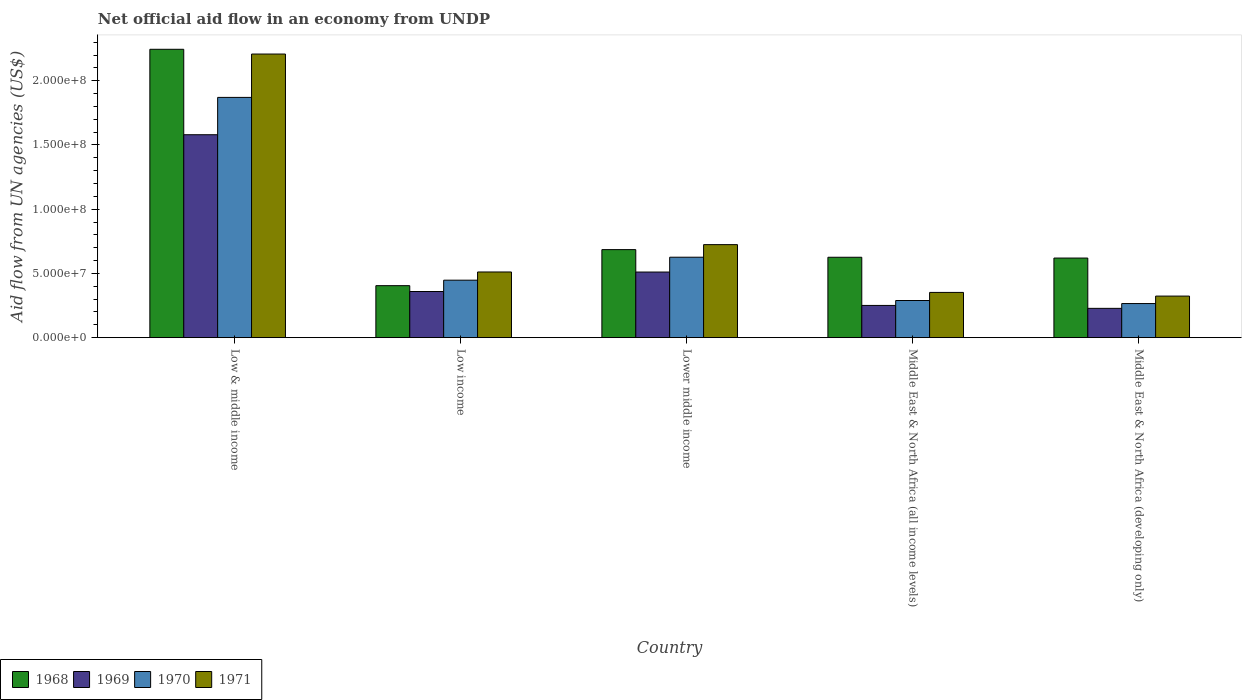Are the number of bars per tick equal to the number of legend labels?
Give a very brief answer. Yes. Are the number of bars on each tick of the X-axis equal?
Offer a terse response. Yes. What is the net official aid flow in 1969 in Middle East & North Africa (all income levels)?
Provide a succinct answer. 2.51e+07. Across all countries, what is the maximum net official aid flow in 1968?
Give a very brief answer. 2.24e+08. Across all countries, what is the minimum net official aid flow in 1969?
Provide a succinct answer. 2.28e+07. In which country was the net official aid flow in 1969 minimum?
Keep it short and to the point. Middle East & North Africa (developing only). What is the total net official aid flow in 1968 in the graph?
Make the answer very short. 4.58e+08. What is the difference between the net official aid flow in 1971 in Lower middle income and that in Middle East & North Africa (all income levels)?
Provide a succinct answer. 3.72e+07. What is the difference between the net official aid flow in 1970 in Lower middle income and the net official aid flow in 1969 in Low income?
Offer a very short reply. 2.67e+07. What is the average net official aid flow in 1968 per country?
Provide a short and direct response. 9.16e+07. What is the difference between the net official aid flow of/in 1971 and net official aid flow of/in 1969 in Lower middle income?
Provide a succinct answer. 2.13e+07. What is the ratio of the net official aid flow in 1970 in Lower middle income to that in Middle East & North Africa (all income levels)?
Provide a short and direct response. 2.17. What is the difference between the highest and the second highest net official aid flow in 1971?
Keep it short and to the point. 1.70e+08. What is the difference between the highest and the lowest net official aid flow in 1969?
Provide a succinct answer. 1.35e+08. Is it the case that in every country, the sum of the net official aid flow in 1970 and net official aid flow in 1969 is greater than the sum of net official aid flow in 1971 and net official aid flow in 1968?
Your answer should be compact. No. What does the 1st bar from the right in Low income represents?
Offer a very short reply. 1971. Is it the case that in every country, the sum of the net official aid flow in 1971 and net official aid flow in 1968 is greater than the net official aid flow in 1969?
Provide a succinct answer. Yes. How many bars are there?
Provide a short and direct response. 20. Are all the bars in the graph horizontal?
Ensure brevity in your answer.  No. How many countries are there in the graph?
Provide a succinct answer. 5. Are the values on the major ticks of Y-axis written in scientific E-notation?
Keep it short and to the point. Yes. Where does the legend appear in the graph?
Give a very brief answer. Bottom left. How are the legend labels stacked?
Your response must be concise. Horizontal. What is the title of the graph?
Your response must be concise. Net official aid flow in an economy from UNDP. What is the label or title of the Y-axis?
Provide a short and direct response. Aid flow from UN agencies (US$). What is the Aid flow from UN agencies (US$) of 1968 in Low & middle income?
Give a very brief answer. 2.24e+08. What is the Aid flow from UN agencies (US$) of 1969 in Low & middle income?
Ensure brevity in your answer.  1.58e+08. What is the Aid flow from UN agencies (US$) in 1970 in Low & middle income?
Your response must be concise. 1.87e+08. What is the Aid flow from UN agencies (US$) in 1971 in Low & middle income?
Provide a short and direct response. 2.21e+08. What is the Aid flow from UN agencies (US$) of 1968 in Low income?
Your answer should be very brief. 4.05e+07. What is the Aid flow from UN agencies (US$) in 1969 in Low income?
Ensure brevity in your answer.  3.59e+07. What is the Aid flow from UN agencies (US$) in 1970 in Low income?
Offer a terse response. 4.48e+07. What is the Aid flow from UN agencies (US$) of 1971 in Low income?
Keep it short and to the point. 5.11e+07. What is the Aid flow from UN agencies (US$) in 1968 in Lower middle income?
Your answer should be compact. 6.85e+07. What is the Aid flow from UN agencies (US$) of 1969 in Lower middle income?
Your answer should be very brief. 5.11e+07. What is the Aid flow from UN agencies (US$) of 1970 in Lower middle income?
Your answer should be very brief. 6.26e+07. What is the Aid flow from UN agencies (US$) of 1971 in Lower middle income?
Offer a very short reply. 7.24e+07. What is the Aid flow from UN agencies (US$) in 1968 in Middle East & North Africa (all income levels)?
Keep it short and to the point. 6.26e+07. What is the Aid flow from UN agencies (US$) of 1969 in Middle East & North Africa (all income levels)?
Make the answer very short. 2.51e+07. What is the Aid flow from UN agencies (US$) in 1970 in Middle East & North Africa (all income levels)?
Provide a succinct answer. 2.89e+07. What is the Aid flow from UN agencies (US$) in 1971 in Middle East & North Africa (all income levels)?
Offer a very short reply. 3.52e+07. What is the Aid flow from UN agencies (US$) in 1968 in Middle East & North Africa (developing only)?
Give a very brief answer. 6.20e+07. What is the Aid flow from UN agencies (US$) in 1969 in Middle East & North Africa (developing only)?
Your answer should be compact. 2.28e+07. What is the Aid flow from UN agencies (US$) in 1970 in Middle East & North Africa (developing only)?
Provide a short and direct response. 2.66e+07. What is the Aid flow from UN agencies (US$) of 1971 in Middle East & North Africa (developing only)?
Offer a very short reply. 3.24e+07. Across all countries, what is the maximum Aid flow from UN agencies (US$) of 1968?
Provide a short and direct response. 2.24e+08. Across all countries, what is the maximum Aid flow from UN agencies (US$) of 1969?
Give a very brief answer. 1.58e+08. Across all countries, what is the maximum Aid flow from UN agencies (US$) of 1970?
Ensure brevity in your answer.  1.87e+08. Across all countries, what is the maximum Aid flow from UN agencies (US$) in 1971?
Ensure brevity in your answer.  2.21e+08. Across all countries, what is the minimum Aid flow from UN agencies (US$) of 1968?
Keep it short and to the point. 4.05e+07. Across all countries, what is the minimum Aid flow from UN agencies (US$) in 1969?
Keep it short and to the point. 2.28e+07. Across all countries, what is the minimum Aid flow from UN agencies (US$) in 1970?
Provide a succinct answer. 2.66e+07. Across all countries, what is the minimum Aid flow from UN agencies (US$) of 1971?
Offer a very short reply. 3.24e+07. What is the total Aid flow from UN agencies (US$) of 1968 in the graph?
Your answer should be very brief. 4.58e+08. What is the total Aid flow from UN agencies (US$) of 1969 in the graph?
Ensure brevity in your answer.  2.93e+08. What is the total Aid flow from UN agencies (US$) of 1970 in the graph?
Your response must be concise. 3.50e+08. What is the total Aid flow from UN agencies (US$) in 1971 in the graph?
Keep it short and to the point. 4.12e+08. What is the difference between the Aid flow from UN agencies (US$) of 1968 in Low & middle income and that in Low income?
Keep it short and to the point. 1.84e+08. What is the difference between the Aid flow from UN agencies (US$) in 1969 in Low & middle income and that in Low income?
Provide a short and direct response. 1.22e+08. What is the difference between the Aid flow from UN agencies (US$) in 1970 in Low & middle income and that in Low income?
Ensure brevity in your answer.  1.42e+08. What is the difference between the Aid flow from UN agencies (US$) in 1971 in Low & middle income and that in Low income?
Give a very brief answer. 1.70e+08. What is the difference between the Aid flow from UN agencies (US$) of 1968 in Low & middle income and that in Lower middle income?
Your response must be concise. 1.56e+08. What is the difference between the Aid flow from UN agencies (US$) in 1969 in Low & middle income and that in Lower middle income?
Your answer should be compact. 1.07e+08. What is the difference between the Aid flow from UN agencies (US$) of 1970 in Low & middle income and that in Lower middle income?
Your answer should be very brief. 1.24e+08. What is the difference between the Aid flow from UN agencies (US$) of 1971 in Low & middle income and that in Lower middle income?
Your response must be concise. 1.48e+08. What is the difference between the Aid flow from UN agencies (US$) in 1968 in Low & middle income and that in Middle East & North Africa (all income levels)?
Keep it short and to the point. 1.62e+08. What is the difference between the Aid flow from UN agencies (US$) in 1969 in Low & middle income and that in Middle East & North Africa (all income levels)?
Your answer should be very brief. 1.33e+08. What is the difference between the Aid flow from UN agencies (US$) of 1970 in Low & middle income and that in Middle East & North Africa (all income levels)?
Your answer should be very brief. 1.58e+08. What is the difference between the Aid flow from UN agencies (US$) in 1971 in Low & middle income and that in Middle East & North Africa (all income levels)?
Give a very brief answer. 1.86e+08. What is the difference between the Aid flow from UN agencies (US$) of 1968 in Low & middle income and that in Middle East & North Africa (developing only)?
Offer a terse response. 1.63e+08. What is the difference between the Aid flow from UN agencies (US$) of 1969 in Low & middle income and that in Middle East & North Africa (developing only)?
Your answer should be very brief. 1.35e+08. What is the difference between the Aid flow from UN agencies (US$) in 1970 in Low & middle income and that in Middle East & North Africa (developing only)?
Make the answer very short. 1.60e+08. What is the difference between the Aid flow from UN agencies (US$) of 1971 in Low & middle income and that in Middle East & North Africa (developing only)?
Make the answer very short. 1.88e+08. What is the difference between the Aid flow from UN agencies (US$) of 1968 in Low income and that in Lower middle income?
Provide a short and direct response. -2.81e+07. What is the difference between the Aid flow from UN agencies (US$) in 1969 in Low income and that in Lower middle income?
Give a very brief answer. -1.52e+07. What is the difference between the Aid flow from UN agencies (US$) in 1970 in Low income and that in Lower middle income?
Provide a succinct answer. -1.79e+07. What is the difference between the Aid flow from UN agencies (US$) of 1971 in Low income and that in Lower middle income?
Your response must be concise. -2.13e+07. What is the difference between the Aid flow from UN agencies (US$) in 1968 in Low income and that in Middle East & North Africa (all income levels)?
Make the answer very short. -2.21e+07. What is the difference between the Aid flow from UN agencies (US$) of 1969 in Low income and that in Middle East & North Africa (all income levels)?
Ensure brevity in your answer.  1.08e+07. What is the difference between the Aid flow from UN agencies (US$) in 1970 in Low income and that in Middle East & North Africa (all income levels)?
Your response must be concise. 1.58e+07. What is the difference between the Aid flow from UN agencies (US$) of 1971 in Low income and that in Middle East & North Africa (all income levels)?
Your answer should be very brief. 1.59e+07. What is the difference between the Aid flow from UN agencies (US$) in 1968 in Low income and that in Middle East & North Africa (developing only)?
Give a very brief answer. -2.15e+07. What is the difference between the Aid flow from UN agencies (US$) in 1969 in Low income and that in Middle East & North Africa (developing only)?
Give a very brief answer. 1.31e+07. What is the difference between the Aid flow from UN agencies (US$) in 1970 in Low income and that in Middle East & North Africa (developing only)?
Keep it short and to the point. 1.82e+07. What is the difference between the Aid flow from UN agencies (US$) in 1971 in Low income and that in Middle East & North Africa (developing only)?
Offer a very short reply. 1.88e+07. What is the difference between the Aid flow from UN agencies (US$) in 1968 in Lower middle income and that in Middle East & North Africa (all income levels)?
Make the answer very short. 5.95e+06. What is the difference between the Aid flow from UN agencies (US$) of 1969 in Lower middle income and that in Middle East & North Africa (all income levels)?
Your response must be concise. 2.60e+07. What is the difference between the Aid flow from UN agencies (US$) of 1970 in Lower middle income and that in Middle East & North Africa (all income levels)?
Your answer should be very brief. 3.37e+07. What is the difference between the Aid flow from UN agencies (US$) in 1971 in Lower middle income and that in Middle East & North Africa (all income levels)?
Provide a succinct answer. 3.72e+07. What is the difference between the Aid flow from UN agencies (US$) in 1968 in Lower middle income and that in Middle East & North Africa (developing only)?
Keep it short and to the point. 6.57e+06. What is the difference between the Aid flow from UN agencies (US$) in 1969 in Lower middle income and that in Middle East & North Africa (developing only)?
Offer a very short reply. 2.83e+07. What is the difference between the Aid flow from UN agencies (US$) of 1970 in Lower middle income and that in Middle East & North Africa (developing only)?
Your answer should be compact. 3.61e+07. What is the difference between the Aid flow from UN agencies (US$) of 1971 in Lower middle income and that in Middle East & North Africa (developing only)?
Provide a short and direct response. 4.01e+07. What is the difference between the Aid flow from UN agencies (US$) in 1968 in Middle East & North Africa (all income levels) and that in Middle East & North Africa (developing only)?
Your answer should be compact. 6.20e+05. What is the difference between the Aid flow from UN agencies (US$) in 1969 in Middle East & North Africa (all income levels) and that in Middle East & North Africa (developing only)?
Your answer should be very brief. 2.27e+06. What is the difference between the Aid flow from UN agencies (US$) in 1970 in Middle East & North Africa (all income levels) and that in Middle East & North Africa (developing only)?
Your response must be concise. 2.37e+06. What is the difference between the Aid flow from UN agencies (US$) of 1971 in Middle East & North Africa (all income levels) and that in Middle East & North Africa (developing only)?
Your answer should be very brief. 2.87e+06. What is the difference between the Aid flow from UN agencies (US$) of 1968 in Low & middle income and the Aid flow from UN agencies (US$) of 1969 in Low income?
Keep it short and to the point. 1.89e+08. What is the difference between the Aid flow from UN agencies (US$) in 1968 in Low & middle income and the Aid flow from UN agencies (US$) in 1970 in Low income?
Keep it short and to the point. 1.80e+08. What is the difference between the Aid flow from UN agencies (US$) in 1968 in Low & middle income and the Aid flow from UN agencies (US$) in 1971 in Low income?
Ensure brevity in your answer.  1.73e+08. What is the difference between the Aid flow from UN agencies (US$) of 1969 in Low & middle income and the Aid flow from UN agencies (US$) of 1970 in Low income?
Offer a very short reply. 1.13e+08. What is the difference between the Aid flow from UN agencies (US$) in 1969 in Low & middle income and the Aid flow from UN agencies (US$) in 1971 in Low income?
Give a very brief answer. 1.07e+08. What is the difference between the Aid flow from UN agencies (US$) of 1970 in Low & middle income and the Aid flow from UN agencies (US$) of 1971 in Low income?
Keep it short and to the point. 1.36e+08. What is the difference between the Aid flow from UN agencies (US$) in 1968 in Low & middle income and the Aid flow from UN agencies (US$) in 1969 in Lower middle income?
Your answer should be very brief. 1.73e+08. What is the difference between the Aid flow from UN agencies (US$) in 1968 in Low & middle income and the Aid flow from UN agencies (US$) in 1970 in Lower middle income?
Offer a very short reply. 1.62e+08. What is the difference between the Aid flow from UN agencies (US$) in 1968 in Low & middle income and the Aid flow from UN agencies (US$) in 1971 in Lower middle income?
Your answer should be compact. 1.52e+08. What is the difference between the Aid flow from UN agencies (US$) in 1969 in Low & middle income and the Aid flow from UN agencies (US$) in 1970 in Lower middle income?
Your response must be concise. 9.54e+07. What is the difference between the Aid flow from UN agencies (US$) in 1969 in Low & middle income and the Aid flow from UN agencies (US$) in 1971 in Lower middle income?
Provide a short and direct response. 8.56e+07. What is the difference between the Aid flow from UN agencies (US$) of 1970 in Low & middle income and the Aid flow from UN agencies (US$) of 1971 in Lower middle income?
Your answer should be compact. 1.15e+08. What is the difference between the Aid flow from UN agencies (US$) in 1968 in Low & middle income and the Aid flow from UN agencies (US$) in 1969 in Middle East & North Africa (all income levels)?
Your answer should be very brief. 1.99e+08. What is the difference between the Aid flow from UN agencies (US$) in 1968 in Low & middle income and the Aid flow from UN agencies (US$) in 1970 in Middle East & North Africa (all income levels)?
Your answer should be compact. 1.96e+08. What is the difference between the Aid flow from UN agencies (US$) in 1968 in Low & middle income and the Aid flow from UN agencies (US$) in 1971 in Middle East & North Africa (all income levels)?
Provide a short and direct response. 1.89e+08. What is the difference between the Aid flow from UN agencies (US$) of 1969 in Low & middle income and the Aid flow from UN agencies (US$) of 1970 in Middle East & North Africa (all income levels)?
Provide a succinct answer. 1.29e+08. What is the difference between the Aid flow from UN agencies (US$) in 1969 in Low & middle income and the Aid flow from UN agencies (US$) in 1971 in Middle East & North Africa (all income levels)?
Your answer should be compact. 1.23e+08. What is the difference between the Aid flow from UN agencies (US$) of 1970 in Low & middle income and the Aid flow from UN agencies (US$) of 1971 in Middle East & North Africa (all income levels)?
Give a very brief answer. 1.52e+08. What is the difference between the Aid flow from UN agencies (US$) in 1968 in Low & middle income and the Aid flow from UN agencies (US$) in 1969 in Middle East & North Africa (developing only)?
Offer a terse response. 2.02e+08. What is the difference between the Aid flow from UN agencies (US$) in 1968 in Low & middle income and the Aid flow from UN agencies (US$) in 1970 in Middle East & North Africa (developing only)?
Make the answer very short. 1.98e+08. What is the difference between the Aid flow from UN agencies (US$) in 1968 in Low & middle income and the Aid flow from UN agencies (US$) in 1971 in Middle East & North Africa (developing only)?
Keep it short and to the point. 1.92e+08. What is the difference between the Aid flow from UN agencies (US$) of 1969 in Low & middle income and the Aid flow from UN agencies (US$) of 1970 in Middle East & North Africa (developing only)?
Keep it short and to the point. 1.31e+08. What is the difference between the Aid flow from UN agencies (US$) of 1969 in Low & middle income and the Aid flow from UN agencies (US$) of 1971 in Middle East & North Africa (developing only)?
Give a very brief answer. 1.26e+08. What is the difference between the Aid flow from UN agencies (US$) of 1970 in Low & middle income and the Aid flow from UN agencies (US$) of 1971 in Middle East & North Africa (developing only)?
Provide a short and direct response. 1.55e+08. What is the difference between the Aid flow from UN agencies (US$) of 1968 in Low income and the Aid flow from UN agencies (US$) of 1969 in Lower middle income?
Give a very brief answer. -1.06e+07. What is the difference between the Aid flow from UN agencies (US$) of 1968 in Low income and the Aid flow from UN agencies (US$) of 1970 in Lower middle income?
Provide a short and direct response. -2.22e+07. What is the difference between the Aid flow from UN agencies (US$) of 1968 in Low income and the Aid flow from UN agencies (US$) of 1971 in Lower middle income?
Make the answer very short. -3.19e+07. What is the difference between the Aid flow from UN agencies (US$) in 1969 in Low income and the Aid flow from UN agencies (US$) in 1970 in Lower middle income?
Your answer should be very brief. -2.67e+07. What is the difference between the Aid flow from UN agencies (US$) of 1969 in Low income and the Aid flow from UN agencies (US$) of 1971 in Lower middle income?
Offer a very short reply. -3.65e+07. What is the difference between the Aid flow from UN agencies (US$) in 1970 in Low income and the Aid flow from UN agencies (US$) in 1971 in Lower middle income?
Your answer should be very brief. -2.77e+07. What is the difference between the Aid flow from UN agencies (US$) of 1968 in Low income and the Aid flow from UN agencies (US$) of 1969 in Middle East & North Africa (all income levels)?
Keep it short and to the point. 1.54e+07. What is the difference between the Aid flow from UN agencies (US$) of 1968 in Low income and the Aid flow from UN agencies (US$) of 1970 in Middle East & North Africa (all income levels)?
Offer a very short reply. 1.16e+07. What is the difference between the Aid flow from UN agencies (US$) in 1968 in Low income and the Aid flow from UN agencies (US$) in 1971 in Middle East & North Africa (all income levels)?
Your answer should be compact. 5.25e+06. What is the difference between the Aid flow from UN agencies (US$) of 1969 in Low income and the Aid flow from UN agencies (US$) of 1970 in Middle East & North Africa (all income levels)?
Offer a very short reply. 7.01e+06. What is the difference between the Aid flow from UN agencies (US$) of 1970 in Low income and the Aid flow from UN agencies (US$) of 1971 in Middle East & North Africa (all income levels)?
Make the answer very short. 9.52e+06. What is the difference between the Aid flow from UN agencies (US$) in 1968 in Low income and the Aid flow from UN agencies (US$) in 1969 in Middle East & North Africa (developing only)?
Offer a very short reply. 1.77e+07. What is the difference between the Aid flow from UN agencies (US$) in 1968 in Low income and the Aid flow from UN agencies (US$) in 1970 in Middle East & North Africa (developing only)?
Keep it short and to the point. 1.39e+07. What is the difference between the Aid flow from UN agencies (US$) in 1968 in Low income and the Aid flow from UN agencies (US$) in 1971 in Middle East & North Africa (developing only)?
Keep it short and to the point. 8.12e+06. What is the difference between the Aid flow from UN agencies (US$) of 1969 in Low income and the Aid flow from UN agencies (US$) of 1970 in Middle East & North Africa (developing only)?
Your answer should be very brief. 9.38e+06. What is the difference between the Aid flow from UN agencies (US$) of 1969 in Low income and the Aid flow from UN agencies (US$) of 1971 in Middle East & North Africa (developing only)?
Offer a very short reply. 3.57e+06. What is the difference between the Aid flow from UN agencies (US$) in 1970 in Low income and the Aid flow from UN agencies (US$) in 1971 in Middle East & North Africa (developing only)?
Provide a succinct answer. 1.24e+07. What is the difference between the Aid flow from UN agencies (US$) in 1968 in Lower middle income and the Aid flow from UN agencies (US$) in 1969 in Middle East & North Africa (all income levels)?
Keep it short and to the point. 4.34e+07. What is the difference between the Aid flow from UN agencies (US$) of 1968 in Lower middle income and the Aid flow from UN agencies (US$) of 1970 in Middle East & North Africa (all income levels)?
Keep it short and to the point. 3.96e+07. What is the difference between the Aid flow from UN agencies (US$) of 1968 in Lower middle income and the Aid flow from UN agencies (US$) of 1971 in Middle East & North Africa (all income levels)?
Ensure brevity in your answer.  3.33e+07. What is the difference between the Aid flow from UN agencies (US$) in 1969 in Lower middle income and the Aid flow from UN agencies (US$) in 1970 in Middle East & North Africa (all income levels)?
Offer a very short reply. 2.22e+07. What is the difference between the Aid flow from UN agencies (US$) of 1969 in Lower middle income and the Aid flow from UN agencies (US$) of 1971 in Middle East & North Africa (all income levels)?
Offer a very short reply. 1.59e+07. What is the difference between the Aid flow from UN agencies (US$) of 1970 in Lower middle income and the Aid flow from UN agencies (US$) of 1971 in Middle East & North Africa (all income levels)?
Your answer should be very brief. 2.74e+07. What is the difference between the Aid flow from UN agencies (US$) in 1968 in Lower middle income and the Aid flow from UN agencies (US$) in 1969 in Middle East & North Africa (developing only)?
Your answer should be compact. 4.57e+07. What is the difference between the Aid flow from UN agencies (US$) in 1968 in Lower middle income and the Aid flow from UN agencies (US$) in 1970 in Middle East & North Africa (developing only)?
Keep it short and to the point. 4.20e+07. What is the difference between the Aid flow from UN agencies (US$) of 1968 in Lower middle income and the Aid flow from UN agencies (US$) of 1971 in Middle East & North Africa (developing only)?
Keep it short and to the point. 3.62e+07. What is the difference between the Aid flow from UN agencies (US$) of 1969 in Lower middle income and the Aid flow from UN agencies (US$) of 1970 in Middle East & North Africa (developing only)?
Provide a short and direct response. 2.45e+07. What is the difference between the Aid flow from UN agencies (US$) in 1969 in Lower middle income and the Aid flow from UN agencies (US$) in 1971 in Middle East & North Africa (developing only)?
Make the answer very short. 1.87e+07. What is the difference between the Aid flow from UN agencies (US$) of 1970 in Lower middle income and the Aid flow from UN agencies (US$) of 1971 in Middle East & North Africa (developing only)?
Give a very brief answer. 3.03e+07. What is the difference between the Aid flow from UN agencies (US$) of 1968 in Middle East & North Africa (all income levels) and the Aid flow from UN agencies (US$) of 1969 in Middle East & North Africa (developing only)?
Give a very brief answer. 3.98e+07. What is the difference between the Aid flow from UN agencies (US$) in 1968 in Middle East & North Africa (all income levels) and the Aid flow from UN agencies (US$) in 1970 in Middle East & North Africa (developing only)?
Offer a very short reply. 3.60e+07. What is the difference between the Aid flow from UN agencies (US$) of 1968 in Middle East & North Africa (all income levels) and the Aid flow from UN agencies (US$) of 1971 in Middle East & North Africa (developing only)?
Provide a succinct answer. 3.02e+07. What is the difference between the Aid flow from UN agencies (US$) of 1969 in Middle East & North Africa (all income levels) and the Aid flow from UN agencies (US$) of 1970 in Middle East & North Africa (developing only)?
Keep it short and to the point. -1.46e+06. What is the difference between the Aid flow from UN agencies (US$) in 1969 in Middle East & North Africa (all income levels) and the Aid flow from UN agencies (US$) in 1971 in Middle East & North Africa (developing only)?
Offer a very short reply. -7.27e+06. What is the difference between the Aid flow from UN agencies (US$) of 1970 in Middle East & North Africa (all income levels) and the Aid flow from UN agencies (US$) of 1971 in Middle East & North Africa (developing only)?
Offer a terse response. -3.44e+06. What is the average Aid flow from UN agencies (US$) in 1968 per country?
Give a very brief answer. 9.16e+07. What is the average Aid flow from UN agencies (US$) of 1969 per country?
Provide a succinct answer. 5.86e+07. What is the average Aid flow from UN agencies (US$) of 1970 per country?
Provide a short and direct response. 7.00e+07. What is the average Aid flow from UN agencies (US$) of 1971 per country?
Make the answer very short. 8.24e+07. What is the difference between the Aid flow from UN agencies (US$) in 1968 and Aid flow from UN agencies (US$) in 1969 in Low & middle income?
Provide a short and direct response. 6.65e+07. What is the difference between the Aid flow from UN agencies (US$) in 1968 and Aid flow from UN agencies (US$) in 1970 in Low & middle income?
Offer a very short reply. 3.74e+07. What is the difference between the Aid flow from UN agencies (US$) in 1968 and Aid flow from UN agencies (US$) in 1971 in Low & middle income?
Offer a very short reply. 3.70e+06. What is the difference between the Aid flow from UN agencies (US$) in 1969 and Aid flow from UN agencies (US$) in 1970 in Low & middle income?
Your answer should be compact. -2.90e+07. What is the difference between the Aid flow from UN agencies (US$) of 1969 and Aid flow from UN agencies (US$) of 1971 in Low & middle income?
Provide a short and direct response. -6.28e+07. What is the difference between the Aid flow from UN agencies (US$) in 1970 and Aid flow from UN agencies (US$) in 1971 in Low & middle income?
Give a very brief answer. -3.38e+07. What is the difference between the Aid flow from UN agencies (US$) of 1968 and Aid flow from UN agencies (US$) of 1969 in Low income?
Provide a short and direct response. 4.55e+06. What is the difference between the Aid flow from UN agencies (US$) of 1968 and Aid flow from UN agencies (US$) of 1970 in Low income?
Your answer should be compact. -4.27e+06. What is the difference between the Aid flow from UN agencies (US$) of 1968 and Aid flow from UN agencies (US$) of 1971 in Low income?
Your answer should be compact. -1.06e+07. What is the difference between the Aid flow from UN agencies (US$) in 1969 and Aid flow from UN agencies (US$) in 1970 in Low income?
Provide a short and direct response. -8.82e+06. What is the difference between the Aid flow from UN agencies (US$) in 1969 and Aid flow from UN agencies (US$) in 1971 in Low income?
Offer a terse response. -1.52e+07. What is the difference between the Aid flow from UN agencies (US$) of 1970 and Aid flow from UN agencies (US$) of 1971 in Low income?
Your response must be concise. -6.38e+06. What is the difference between the Aid flow from UN agencies (US$) of 1968 and Aid flow from UN agencies (US$) of 1969 in Lower middle income?
Your answer should be very brief. 1.74e+07. What is the difference between the Aid flow from UN agencies (US$) in 1968 and Aid flow from UN agencies (US$) in 1970 in Lower middle income?
Give a very brief answer. 5.91e+06. What is the difference between the Aid flow from UN agencies (US$) in 1968 and Aid flow from UN agencies (US$) in 1971 in Lower middle income?
Your answer should be very brief. -3.88e+06. What is the difference between the Aid flow from UN agencies (US$) of 1969 and Aid flow from UN agencies (US$) of 1970 in Lower middle income?
Your answer should be compact. -1.15e+07. What is the difference between the Aid flow from UN agencies (US$) of 1969 and Aid flow from UN agencies (US$) of 1971 in Lower middle income?
Your answer should be very brief. -2.13e+07. What is the difference between the Aid flow from UN agencies (US$) in 1970 and Aid flow from UN agencies (US$) in 1971 in Lower middle income?
Offer a terse response. -9.79e+06. What is the difference between the Aid flow from UN agencies (US$) in 1968 and Aid flow from UN agencies (US$) in 1969 in Middle East & North Africa (all income levels)?
Keep it short and to the point. 3.75e+07. What is the difference between the Aid flow from UN agencies (US$) in 1968 and Aid flow from UN agencies (US$) in 1970 in Middle East & North Africa (all income levels)?
Ensure brevity in your answer.  3.37e+07. What is the difference between the Aid flow from UN agencies (US$) in 1968 and Aid flow from UN agencies (US$) in 1971 in Middle East & North Africa (all income levels)?
Offer a terse response. 2.74e+07. What is the difference between the Aid flow from UN agencies (US$) of 1969 and Aid flow from UN agencies (US$) of 1970 in Middle East & North Africa (all income levels)?
Your response must be concise. -3.83e+06. What is the difference between the Aid flow from UN agencies (US$) in 1969 and Aid flow from UN agencies (US$) in 1971 in Middle East & North Africa (all income levels)?
Your response must be concise. -1.01e+07. What is the difference between the Aid flow from UN agencies (US$) of 1970 and Aid flow from UN agencies (US$) of 1971 in Middle East & North Africa (all income levels)?
Give a very brief answer. -6.31e+06. What is the difference between the Aid flow from UN agencies (US$) in 1968 and Aid flow from UN agencies (US$) in 1969 in Middle East & North Africa (developing only)?
Keep it short and to the point. 3.92e+07. What is the difference between the Aid flow from UN agencies (US$) in 1968 and Aid flow from UN agencies (US$) in 1970 in Middle East & North Africa (developing only)?
Your answer should be compact. 3.54e+07. What is the difference between the Aid flow from UN agencies (US$) of 1968 and Aid flow from UN agencies (US$) of 1971 in Middle East & North Africa (developing only)?
Keep it short and to the point. 2.96e+07. What is the difference between the Aid flow from UN agencies (US$) of 1969 and Aid flow from UN agencies (US$) of 1970 in Middle East & North Africa (developing only)?
Provide a short and direct response. -3.73e+06. What is the difference between the Aid flow from UN agencies (US$) of 1969 and Aid flow from UN agencies (US$) of 1971 in Middle East & North Africa (developing only)?
Offer a very short reply. -9.54e+06. What is the difference between the Aid flow from UN agencies (US$) in 1970 and Aid flow from UN agencies (US$) in 1971 in Middle East & North Africa (developing only)?
Ensure brevity in your answer.  -5.81e+06. What is the ratio of the Aid flow from UN agencies (US$) of 1968 in Low & middle income to that in Low income?
Give a very brief answer. 5.55. What is the ratio of the Aid flow from UN agencies (US$) in 1969 in Low & middle income to that in Low income?
Your answer should be compact. 4.4. What is the ratio of the Aid flow from UN agencies (US$) in 1970 in Low & middle income to that in Low income?
Offer a very short reply. 4.18. What is the ratio of the Aid flow from UN agencies (US$) of 1971 in Low & middle income to that in Low income?
Your answer should be very brief. 4.32. What is the ratio of the Aid flow from UN agencies (US$) of 1968 in Low & middle income to that in Lower middle income?
Make the answer very short. 3.28. What is the ratio of the Aid flow from UN agencies (US$) in 1969 in Low & middle income to that in Lower middle income?
Your answer should be very brief. 3.09. What is the ratio of the Aid flow from UN agencies (US$) in 1970 in Low & middle income to that in Lower middle income?
Ensure brevity in your answer.  2.99. What is the ratio of the Aid flow from UN agencies (US$) in 1971 in Low & middle income to that in Lower middle income?
Make the answer very short. 3.05. What is the ratio of the Aid flow from UN agencies (US$) of 1968 in Low & middle income to that in Middle East & North Africa (all income levels)?
Your response must be concise. 3.59. What is the ratio of the Aid flow from UN agencies (US$) in 1969 in Low & middle income to that in Middle East & North Africa (all income levels)?
Keep it short and to the point. 6.3. What is the ratio of the Aid flow from UN agencies (US$) of 1970 in Low & middle income to that in Middle East & North Africa (all income levels)?
Offer a very short reply. 6.47. What is the ratio of the Aid flow from UN agencies (US$) in 1971 in Low & middle income to that in Middle East & North Africa (all income levels)?
Ensure brevity in your answer.  6.27. What is the ratio of the Aid flow from UN agencies (US$) of 1968 in Low & middle income to that in Middle East & North Africa (developing only)?
Ensure brevity in your answer.  3.62. What is the ratio of the Aid flow from UN agencies (US$) of 1969 in Low & middle income to that in Middle East & North Africa (developing only)?
Make the answer very short. 6.92. What is the ratio of the Aid flow from UN agencies (US$) in 1970 in Low & middle income to that in Middle East & North Africa (developing only)?
Your answer should be very brief. 7.04. What is the ratio of the Aid flow from UN agencies (US$) in 1971 in Low & middle income to that in Middle East & North Africa (developing only)?
Ensure brevity in your answer.  6.82. What is the ratio of the Aid flow from UN agencies (US$) of 1968 in Low income to that in Lower middle income?
Offer a terse response. 0.59. What is the ratio of the Aid flow from UN agencies (US$) of 1969 in Low income to that in Lower middle income?
Provide a short and direct response. 0.7. What is the ratio of the Aid flow from UN agencies (US$) of 1970 in Low income to that in Lower middle income?
Make the answer very short. 0.71. What is the ratio of the Aid flow from UN agencies (US$) of 1971 in Low income to that in Lower middle income?
Keep it short and to the point. 0.71. What is the ratio of the Aid flow from UN agencies (US$) of 1968 in Low income to that in Middle East & North Africa (all income levels)?
Your response must be concise. 0.65. What is the ratio of the Aid flow from UN agencies (US$) of 1969 in Low income to that in Middle East & North Africa (all income levels)?
Provide a short and direct response. 1.43. What is the ratio of the Aid flow from UN agencies (US$) in 1970 in Low income to that in Middle East & North Africa (all income levels)?
Keep it short and to the point. 1.55. What is the ratio of the Aid flow from UN agencies (US$) of 1971 in Low income to that in Middle East & North Africa (all income levels)?
Your answer should be compact. 1.45. What is the ratio of the Aid flow from UN agencies (US$) in 1968 in Low income to that in Middle East & North Africa (developing only)?
Provide a succinct answer. 0.65. What is the ratio of the Aid flow from UN agencies (US$) of 1969 in Low income to that in Middle East & North Africa (developing only)?
Provide a succinct answer. 1.57. What is the ratio of the Aid flow from UN agencies (US$) of 1970 in Low income to that in Middle East & North Africa (developing only)?
Make the answer very short. 1.69. What is the ratio of the Aid flow from UN agencies (US$) in 1971 in Low income to that in Middle East & North Africa (developing only)?
Provide a short and direct response. 1.58. What is the ratio of the Aid flow from UN agencies (US$) in 1968 in Lower middle income to that in Middle East & North Africa (all income levels)?
Your answer should be very brief. 1.1. What is the ratio of the Aid flow from UN agencies (US$) of 1969 in Lower middle income to that in Middle East & North Africa (all income levels)?
Your response must be concise. 2.04. What is the ratio of the Aid flow from UN agencies (US$) in 1970 in Lower middle income to that in Middle East & North Africa (all income levels)?
Your answer should be compact. 2.17. What is the ratio of the Aid flow from UN agencies (US$) of 1971 in Lower middle income to that in Middle East & North Africa (all income levels)?
Your response must be concise. 2.06. What is the ratio of the Aid flow from UN agencies (US$) in 1968 in Lower middle income to that in Middle East & North Africa (developing only)?
Make the answer very short. 1.11. What is the ratio of the Aid flow from UN agencies (US$) of 1969 in Lower middle income to that in Middle East & North Africa (developing only)?
Your response must be concise. 2.24. What is the ratio of the Aid flow from UN agencies (US$) in 1970 in Lower middle income to that in Middle East & North Africa (developing only)?
Offer a very short reply. 2.36. What is the ratio of the Aid flow from UN agencies (US$) of 1971 in Lower middle income to that in Middle East & North Africa (developing only)?
Offer a very short reply. 2.24. What is the ratio of the Aid flow from UN agencies (US$) of 1969 in Middle East & North Africa (all income levels) to that in Middle East & North Africa (developing only)?
Provide a succinct answer. 1.1. What is the ratio of the Aid flow from UN agencies (US$) of 1970 in Middle East & North Africa (all income levels) to that in Middle East & North Africa (developing only)?
Offer a very short reply. 1.09. What is the ratio of the Aid flow from UN agencies (US$) of 1971 in Middle East & North Africa (all income levels) to that in Middle East & North Africa (developing only)?
Your answer should be compact. 1.09. What is the difference between the highest and the second highest Aid flow from UN agencies (US$) of 1968?
Keep it short and to the point. 1.56e+08. What is the difference between the highest and the second highest Aid flow from UN agencies (US$) of 1969?
Your answer should be compact. 1.07e+08. What is the difference between the highest and the second highest Aid flow from UN agencies (US$) in 1970?
Provide a succinct answer. 1.24e+08. What is the difference between the highest and the second highest Aid flow from UN agencies (US$) of 1971?
Your answer should be compact. 1.48e+08. What is the difference between the highest and the lowest Aid flow from UN agencies (US$) of 1968?
Offer a terse response. 1.84e+08. What is the difference between the highest and the lowest Aid flow from UN agencies (US$) of 1969?
Keep it short and to the point. 1.35e+08. What is the difference between the highest and the lowest Aid flow from UN agencies (US$) in 1970?
Provide a short and direct response. 1.60e+08. What is the difference between the highest and the lowest Aid flow from UN agencies (US$) in 1971?
Your answer should be compact. 1.88e+08. 